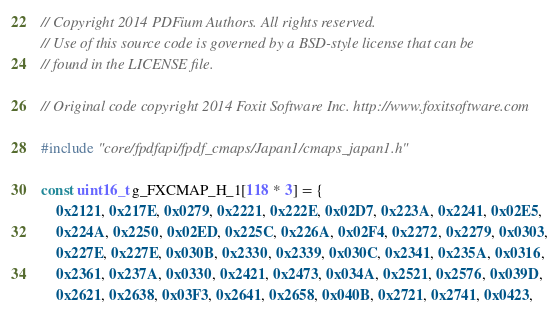<code> <loc_0><loc_0><loc_500><loc_500><_C++_>// Copyright 2014 PDFium Authors. All rights reserved.
// Use of this source code is governed by a BSD-style license that can be
// found in the LICENSE file.

// Original code copyright 2014 Foxit Software Inc. http://www.foxitsoftware.com

#include "core/fpdfapi/fpdf_cmaps/Japan1/cmaps_japan1.h"

const uint16_t g_FXCMAP_H_1[118 * 3] = {
    0x2121, 0x217E, 0x0279, 0x2221, 0x222E, 0x02D7, 0x223A, 0x2241, 0x02E5,
    0x224A, 0x2250, 0x02ED, 0x225C, 0x226A, 0x02F4, 0x2272, 0x2279, 0x0303,
    0x227E, 0x227E, 0x030B, 0x2330, 0x2339, 0x030C, 0x2341, 0x235A, 0x0316,
    0x2361, 0x237A, 0x0330, 0x2421, 0x2473, 0x034A, 0x2521, 0x2576, 0x039D,
    0x2621, 0x2638, 0x03F3, 0x2641, 0x2658, 0x040B, 0x2721, 0x2741, 0x0423,</code> 